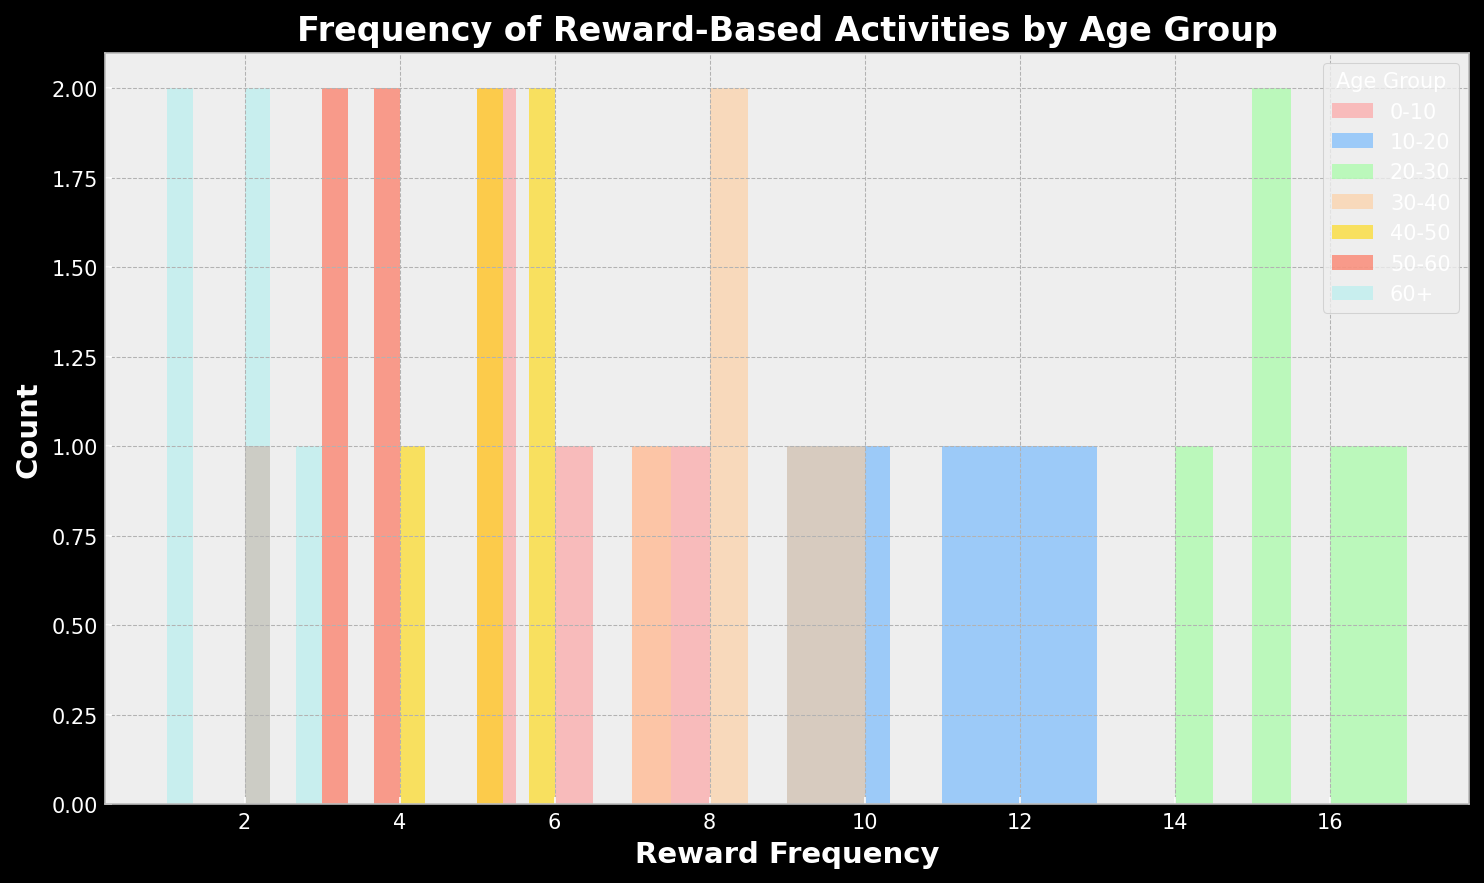What age group has the highest frequency of reward-based activities? The age group with the highest frequency of reward-based activities can be identified by looking at the highest values along the x-axis of the histogram. It appears that the 20-30 age group has the highest frequency, as the bins for this group are around 14-17.
Answer: 20-30 How does the reward frequency for the 10-20 age group compare to the 30-40 age group? To compare these two age groups, we observe the range of frequencies plotted on the x-axis. The 10-20 age group shows frequencies around 9-13, while the 30-40 age group has frequencies in the range of 7-10. Comparing these ranges, the 10-20 age group has a higher frequency overall.
Answer: 10-20 is higher What's the average reward frequency for the 0-10 age group? To find the average, sum up the frequency values (5 + 7 + 6 + 8 + 5) and divide by the number of values (5): Average = (5+7+6+8+5)/5 = 6.2
Answer: 6.2 Which age group has the most varied frequency of reward-based activities? The variability can be gauged by the spread of data within each group's bin range. The 20-30 age group shows a wide spread from 14 to 17, indicating higher variability compared to other groups.
Answer: 20-30 Are there age groups with overlapping reward frequencies? For overlap, we look at the ranges where bins of different colors coincide. The 30-40 age group (7-10) and the 10-20 age group (9-13) overlap in the frequency range of 9-10.
Answer: Yes, 10-20 and 30-40 Which age group shows the least reward-based activities? This can be identified by looking for the lowest frequency bin on the histogram. The 60+ age group shows the lowest frequency bins, ranging from 1 to 3.
Answer: 60+ Describe the visual differences in the height of bars between the 50-60 and 60+ age groups. The bars for the 50-60 age group (frequencies 2-4) are taller than those for the 60+ group (frequencies 1-3). This indicates a higher count of activities for the 50-60 group in the corresponding frequency bins.
Answer: 50-60 has taller bars What can you infer about the activity trend from lower to higher age groups? Observing from 0-10 to 60+, there is an increasing trend in the frequency of reward-based activities until the 20-30 age group, followed by a decrease in the subsequent age groups. This indicates higher engagement in reward activities among younger to mid-aged adults.
Answer: Increases until 20-30, then decreases 